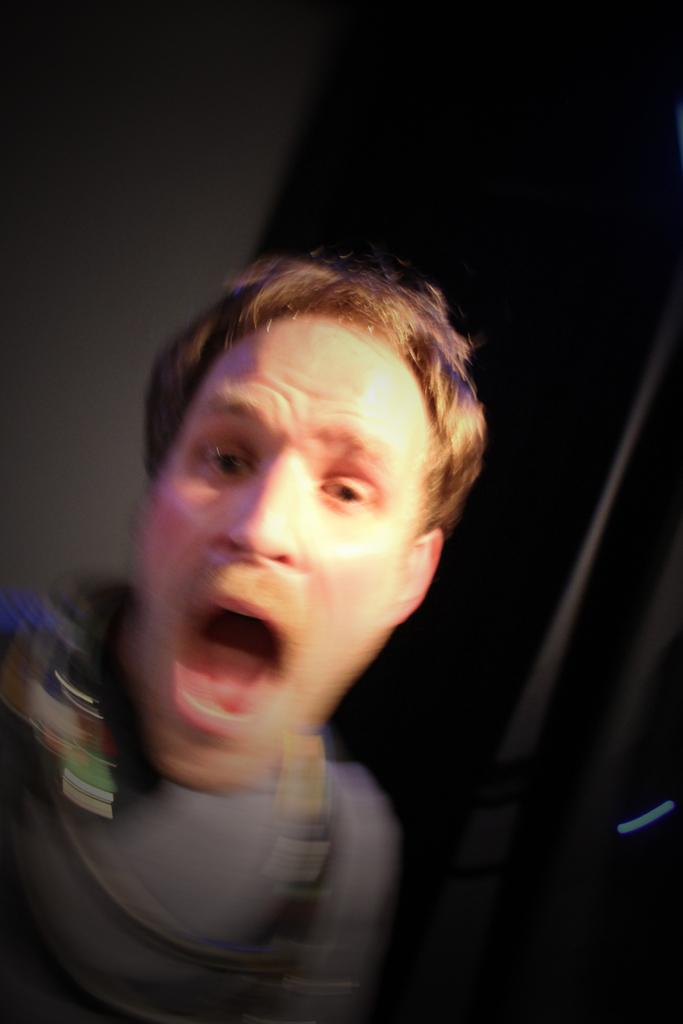What is the main subject of the image? There is a person in the image. Can you describe the background of the image? The background of the image is black and ash colored. How many creatures are part of the flock in the image? There is no flock or creature present in the image; it features a person against a black and ash colored background. 